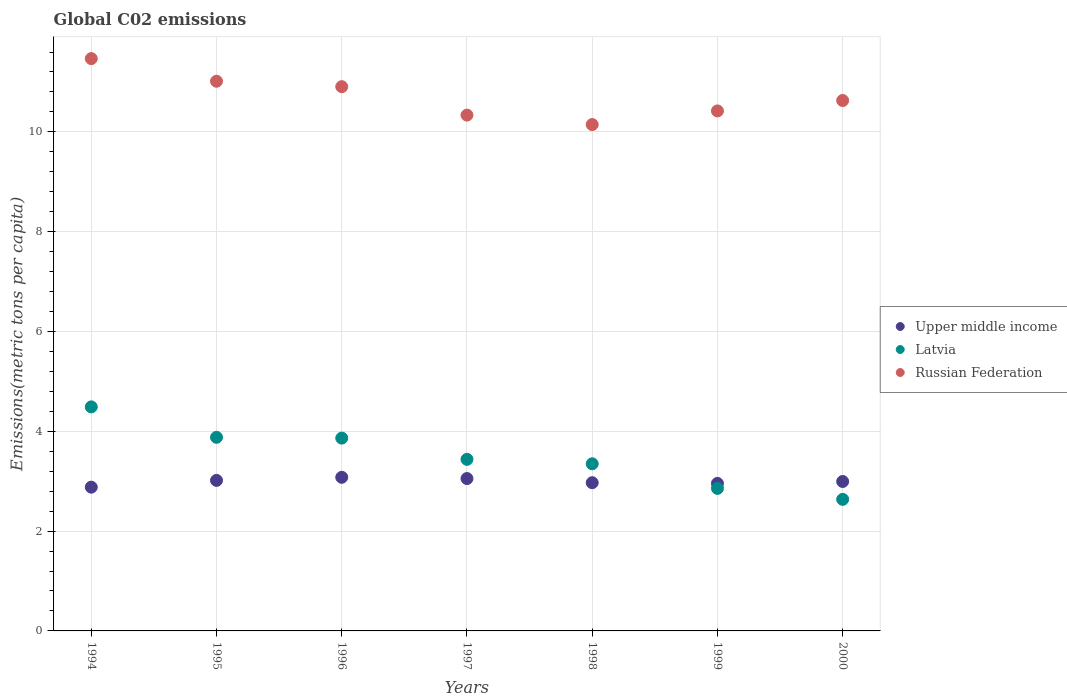How many different coloured dotlines are there?
Give a very brief answer. 3. Is the number of dotlines equal to the number of legend labels?
Your answer should be very brief. Yes. What is the amount of CO2 emitted in in Upper middle income in 2000?
Give a very brief answer. 2.99. Across all years, what is the maximum amount of CO2 emitted in in Upper middle income?
Your answer should be very brief. 3.08. Across all years, what is the minimum amount of CO2 emitted in in Upper middle income?
Give a very brief answer. 2.88. What is the total amount of CO2 emitted in in Latvia in the graph?
Ensure brevity in your answer.  24.51. What is the difference between the amount of CO2 emitted in in Latvia in 1997 and that in 1998?
Your response must be concise. 0.09. What is the difference between the amount of CO2 emitted in in Latvia in 1995 and the amount of CO2 emitted in in Upper middle income in 2000?
Offer a very short reply. 0.88. What is the average amount of CO2 emitted in in Upper middle income per year?
Provide a short and direct response. 2.99. In the year 1997, what is the difference between the amount of CO2 emitted in in Latvia and amount of CO2 emitted in in Upper middle income?
Provide a succinct answer. 0.39. What is the ratio of the amount of CO2 emitted in in Russian Federation in 1995 to that in 1998?
Provide a short and direct response. 1.09. Is the amount of CO2 emitted in in Russian Federation in 1994 less than that in 1995?
Keep it short and to the point. No. Is the difference between the amount of CO2 emitted in in Latvia in 1996 and 2000 greater than the difference between the amount of CO2 emitted in in Upper middle income in 1996 and 2000?
Your answer should be very brief. Yes. What is the difference between the highest and the second highest amount of CO2 emitted in in Russian Federation?
Offer a very short reply. 0.45. What is the difference between the highest and the lowest amount of CO2 emitted in in Latvia?
Provide a short and direct response. 1.85. Does the amount of CO2 emitted in in Latvia monotonically increase over the years?
Your answer should be compact. No. Is the amount of CO2 emitted in in Russian Federation strictly less than the amount of CO2 emitted in in Upper middle income over the years?
Offer a terse response. No. How many years are there in the graph?
Your answer should be compact. 7. What is the difference between two consecutive major ticks on the Y-axis?
Your answer should be compact. 2. Are the values on the major ticks of Y-axis written in scientific E-notation?
Provide a short and direct response. No. Where does the legend appear in the graph?
Give a very brief answer. Center right. How many legend labels are there?
Your answer should be compact. 3. What is the title of the graph?
Provide a short and direct response. Global C02 emissions. Does "Latin America(all income levels)" appear as one of the legend labels in the graph?
Keep it short and to the point. No. What is the label or title of the X-axis?
Provide a short and direct response. Years. What is the label or title of the Y-axis?
Your answer should be compact. Emissions(metric tons per capita). What is the Emissions(metric tons per capita) of Upper middle income in 1994?
Offer a terse response. 2.88. What is the Emissions(metric tons per capita) in Latvia in 1994?
Your response must be concise. 4.49. What is the Emissions(metric tons per capita) of Russian Federation in 1994?
Provide a short and direct response. 11.47. What is the Emissions(metric tons per capita) in Upper middle income in 1995?
Provide a short and direct response. 3.02. What is the Emissions(metric tons per capita) in Latvia in 1995?
Offer a terse response. 3.88. What is the Emissions(metric tons per capita) in Russian Federation in 1995?
Provide a succinct answer. 11.01. What is the Emissions(metric tons per capita) in Upper middle income in 1996?
Keep it short and to the point. 3.08. What is the Emissions(metric tons per capita) in Latvia in 1996?
Offer a very short reply. 3.86. What is the Emissions(metric tons per capita) in Russian Federation in 1996?
Your answer should be compact. 10.91. What is the Emissions(metric tons per capita) of Upper middle income in 1997?
Offer a terse response. 3.05. What is the Emissions(metric tons per capita) in Latvia in 1997?
Provide a short and direct response. 3.44. What is the Emissions(metric tons per capita) in Russian Federation in 1997?
Provide a short and direct response. 10.34. What is the Emissions(metric tons per capita) in Upper middle income in 1998?
Provide a short and direct response. 2.97. What is the Emissions(metric tons per capita) of Latvia in 1998?
Make the answer very short. 3.35. What is the Emissions(metric tons per capita) in Russian Federation in 1998?
Provide a succinct answer. 10.15. What is the Emissions(metric tons per capita) of Upper middle income in 1999?
Ensure brevity in your answer.  2.96. What is the Emissions(metric tons per capita) of Latvia in 1999?
Your answer should be very brief. 2.86. What is the Emissions(metric tons per capita) of Russian Federation in 1999?
Keep it short and to the point. 10.42. What is the Emissions(metric tons per capita) in Upper middle income in 2000?
Your answer should be compact. 2.99. What is the Emissions(metric tons per capita) in Latvia in 2000?
Provide a short and direct response. 2.64. What is the Emissions(metric tons per capita) of Russian Federation in 2000?
Offer a terse response. 10.63. Across all years, what is the maximum Emissions(metric tons per capita) of Upper middle income?
Offer a very short reply. 3.08. Across all years, what is the maximum Emissions(metric tons per capita) of Latvia?
Offer a very short reply. 4.49. Across all years, what is the maximum Emissions(metric tons per capita) of Russian Federation?
Give a very brief answer. 11.47. Across all years, what is the minimum Emissions(metric tons per capita) in Upper middle income?
Make the answer very short. 2.88. Across all years, what is the minimum Emissions(metric tons per capita) in Latvia?
Offer a terse response. 2.64. Across all years, what is the minimum Emissions(metric tons per capita) of Russian Federation?
Provide a short and direct response. 10.15. What is the total Emissions(metric tons per capita) of Upper middle income in the graph?
Offer a terse response. 20.95. What is the total Emissions(metric tons per capita) of Latvia in the graph?
Keep it short and to the point. 24.51. What is the total Emissions(metric tons per capita) in Russian Federation in the graph?
Your answer should be compact. 74.92. What is the difference between the Emissions(metric tons per capita) in Upper middle income in 1994 and that in 1995?
Offer a terse response. -0.14. What is the difference between the Emissions(metric tons per capita) in Latvia in 1994 and that in 1995?
Offer a very short reply. 0.61. What is the difference between the Emissions(metric tons per capita) in Russian Federation in 1994 and that in 1995?
Provide a short and direct response. 0.45. What is the difference between the Emissions(metric tons per capita) in Upper middle income in 1994 and that in 1996?
Offer a terse response. -0.2. What is the difference between the Emissions(metric tons per capita) in Latvia in 1994 and that in 1996?
Provide a short and direct response. 0.63. What is the difference between the Emissions(metric tons per capita) in Russian Federation in 1994 and that in 1996?
Offer a terse response. 0.56. What is the difference between the Emissions(metric tons per capita) of Upper middle income in 1994 and that in 1997?
Provide a succinct answer. -0.17. What is the difference between the Emissions(metric tons per capita) in Latvia in 1994 and that in 1997?
Make the answer very short. 1.05. What is the difference between the Emissions(metric tons per capita) of Russian Federation in 1994 and that in 1997?
Offer a very short reply. 1.13. What is the difference between the Emissions(metric tons per capita) in Upper middle income in 1994 and that in 1998?
Offer a very short reply. -0.09. What is the difference between the Emissions(metric tons per capita) of Latvia in 1994 and that in 1998?
Give a very brief answer. 1.14. What is the difference between the Emissions(metric tons per capita) in Russian Federation in 1994 and that in 1998?
Your response must be concise. 1.32. What is the difference between the Emissions(metric tons per capita) of Upper middle income in 1994 and that in 1999?
Keep it short and to the point. -0.08. What is the difference between the Emissions(metric tons per capita) of Latvia in 1994 and that in 1999?
Your answer should be very brief. 1.63. What is the difference between the Emissions(metric tons per capita) of Russian Federation in 1994 and that in 1999?
Give a very brief answer. 1.05. What is the difference between the Emissions(metric tons per capita) of Upper middle income in 1994 and that in 2000?
Ensure brevity in your answer.  -0.11. What is the difference between the Emissions(metric tons per capita) of Latvia in 1994 and that in 2000?
Provide a succinct answer. 1.85. What is the difference between the Emissions(metric tons per capita) in Russian Federation in 1994 and that in 2000?
Give a very brief answer. 0.84. What is the difference between the Emissions(metric tons per capita) in Upper middle income in 1995 and that in 1996?
Your answer should be very brief. -0.06. What is the difference between the Emissions(metric tons per capita) of Latvia in 1995 and that in 1996?
Offer a terse response. 0.02. What is the difference between the Emissions(metric tons per capita) in Russian Federation in 1995 and that in 1996?
Provide a succinct answer. 0.11. What is the difference between the Emissions(metric tons per capita) of Upper middle income in 1995 and that in 1997?
Offer a very short reply. -0.04. What is the difference between the Emissions(metric tons per capita) in Latvia in 1995 and that in 1997?
Ensure brevity in your answer.  0.44. What is the difference between the Emissions(metric tons per capita) in Russian Federation in 1995 and that in 1997?
Provide a succinct answer. 0.68. What is the difference between the Emissions(metric tons per capita) in Upper middle income in 1995 and that in 1998?
Offer a very short reply. 0.05. What is the difference between the Emissions(metric tons per capita) of Latvia in 1995 and that in 1998?
Provide a succinct answer. 0.53. What is the difference between the Emissions(metric tons per capita) of Russian Federation in 1995 and that in 1998?
Give a very brief answer. 0.87. What is the difference between the Emissions(metric tons per capita) of Upper middle income in 1995 and that in 1999?
Keep it short and to the point. 0.06. What is the difference between the Emissions(metric tons per capita) in Latvia in 1995 and that in 1999?
Your answer should be very brief. 1.02. What is the difference between the Emissions(metric tons per capita) in Russian Federation in 1995 and that in 1999?
Your response must be concise. 0.59. What is the difference between the Emissions(metric tons per capita) in Upper middle income in 1995 and that in 2000?
Ensure brevity in your answer.  0.02. What is the difference between the Emissions(metric tons per capita) of Latvia in 1995 and that in 2000?
Give a very brief answer. 1.24. What is the difference between the Emissions(metric tons per capita) in Russian Federation in 1995 and that in 2000?
Offer a terse response. 0.39. What is the difference between the Emissions(metric tons per capita) in Upper middle income in 1996 and that in 1997?
Your response must be concise. 0.03. What is the difference between the Emissions(metric tons per capita) in Latvia in 1996 and that in 1997?
Ensure brevity in your answer.  0.43. What is the difference between the Emissions(metric tons per capita) of Russian Federation in 1996 and that in 1997?
Give a very brief answer. 0.57. What is the difference between the Emissions(metric tons per capita) in Upper middle income in 1996 and that in 1998?
Your answer should be very brief. 0.11. What is the difference between the Emissions(metric tons per capita) of Latvia in 1996 and that in 1998?
Offer a terse response. 0.51. What is the difference between the Emissions(metric tons per capita) of Russian Federation in 1996 and that in 1998?
Offer a terse response. 0.76. What is the difference between the Emissions(metric tons per capita) of Upper middle income in 1996 and that in 1999?
Offer a terse response. 0.12. What is the difference between the Emissions(metric tons per capita) of Latvia in 1996 and that in 1999?
Offer a very short reply. 1.01. What is the difference between the Emissions(metric tons per capita) of Russian Federation in 1996 and that in 1999?
Offer a terse response. 0.49. What is the difference between the Emissions(metric tons per capita) of Upper middle income in 1996 and that in 2000?
Provide a short and direct response. 0.08. What is the difference between the Emissions(metric tons per capita) of Latvia in 1996 and that in 2000?
Provide a succinct answer. 1.23. What is the difference between the Emissions(metric tons per capita) of Russian Federation in 1996 and that in 2000?
Make the answer very short. 0.28. What is the difference between the Emissions(metric tons per capita) in Upper middle income in 1997 and that in 1998?
Ensure brevity in your answer.  0.08. What is the difference between the Emissions(metric tons per capita) of Latvia in 1997 and that in 1998?
Give a very brief answer. 0.09. What is the difference between the Emissions(metric tons per capita) in Russian Federation in 1997 and that in 1998?
Offer a terse response. 0.19. What is the difference between the Emissions(metric tons per capita) in Upper middle income in 1997 and that in 1999?
Provide a short and direct response. 0.1. What is the difference between the Emissions(metric tons per capita) of Latvia in 1997 and that in 1999?
Your answer should be very brief. 0.58. What is the difference between the Emissions(metric tons per capita) of Russian Federation in 1997 and that in 1999?
Keep it short and to the point. -0.08. What is the difference between the Emissions(metric tons per capita) in Upper middle income in 1997 and that in 2000?
Your response must be concise. 0.06. What is the difference between the Emissions(metric tons per capita) in Latvia in 1997 and that in 2000?
Your answer should be very brief. 0.8. What is the difference between the Emissions(metric tons per capita) of Russian Federation in 1997 and that in 2000?
Provide a succinct answer. -0.29. What is the difference between the Emissions(metric tons per capita) in Upper middle income in 1998 and that in 1999?
Offer a very short reply. 0.01. What is the difference between the Emissions(metric tons per capita) of Latvia in 1998 and that in 1999?
Your answer should be compact. 0.49. What is the difference between the Emissions(metric tons per capita) of Russian Federation in 1998 and that in 1999?
Make the answer very short. -0.27. What is the difference between the Emissions(metric tons per capita) in Upper middle income in 1998 and that in 2000?
Your response must be concise. -0.02. What is the difference between the Emissions(metric tons per capita) in Latvia in 1998 and that in 2000?
Provide a short and direct response. 0.71. What is the difference between the Emissions(metric tons per capita) in Russian Federation in 1998 and that in 2000?
Keep it short and to the point. -0.48. What is the difference between the Emissions(metric tons per capita) of Upper middle income in 1999 and that in 2000?
Your answer should be very brief. -0.04. What is the difference between the Emissions(metric tons per capita) in Latvia in 1999 and that in 2000?
Give a very brief answer. 0.22. What is the difference between the Emissions(metric tons per capita) of Russian Federation in 1999 and that in 2000?
Ensure brevity in your answer.  -0.21. What is the difference between the Emissions(metric tons per capita) of Upper middle income in 1994 and the Emissions(metric tons per capita) of Latvia in 1995?
Offer a terse response. -1. What is the difference between the Emissions(metric tons per capita) in Upper middle income in 1994 and the Emissions(metric tons per capita) in Russian Federation in 1995?
Ensure brevity in your answer.  -8.13. What is the difference between the Emissions(metric tons per capita) of Latvia in 1994 and the Emissions(metric tons per capita) of Russian Federation in 1995?
Offer a terse response. -6.53. What is the difference between the Emissions(metric tons per capita) in Upper middle income in 1994 and the Emissions(metric tons per capita) in Latvia in 1996?
Provide a succinct answer. -0.98. What is the difference between the Emissions(metric tons per capita) in Upper middle income in 1994 and the Emissions(metric tons per capita) in Russian Federation in 1996?
Give a very brief answer. -8.03. What is the difference between the Emissions(metric tons per capita) of Latvia in 1994 and the Emissions(metric tons per capita) of Russian Federation in 1996?
Your answer should be compact. -6.42. What is the difference between the Emissions(metric tons per capita) in Upper middle income in 1994 and the Emissions(metric tons per capita) in Latvia in 1997?
Your answer should be compact. -0.56. What is the difference between the Emissions(metric tons per capita) of Upper middle income in 1994 and the Emissions(metric tons per capita) of Russian Federation in 1997?
Make the answer very short. -7.46. What is the difference between the Emissions(metric tons per capita) in Latvia in 1994 and the Emissions(metric tons per capita) in Russian Federation in 1997?
Give a very brief answer. -5.85. What is the difference between the Emissions(metric tons per capita) in Upper middle income in 1994 and the Emissions(metric tons per capita) in Latvia in 1998?
Offer a very short reply. -0.47. What is the difference between the Emissions(metric tons per capita) in Upper middle income in 1994 and the Emissions(metric tons per capita) in Russian Federation in 1998?
Provide a short and direct response. -7.27. What is the difference between the Emissions(metric tons per capita) of Latvia in 1994 and the Emissions(metric tons per capita) of Russian Federation in 1998?
Ensure brevity in your answer.  -5.66. What is the difference between the Emissions(metric tons per capita) in Upper middle income in 1994 and the Emissions(metric tons per capita) in Latvia in 1999?
Provide a short and direct response. 0.02. What is the difference between the Emissions(metric tons per capita) of Upper middle income in 1994 and the Emissions(metric tons per capita) of Russian Federation in 1999?
Your answer should be very brief. -7.54. What is the difference between the Emissions(metric tons per capita) of Latvia in 1994 and the Emissions(metric tons per capita) of Russian Federation in 1999?
Make the answer very short. -5.93. What is the difference between the Emissions(metric tons per capita) in Upper middle income in 1994 and the Emissions(metric tons per capita) in Latvia in 2000?
Make the answer very short. 0.24. What is the difference between the Emissions(metric tons per capita) of Upper middle income in 1994 and the Emissions(metric tons per capita) of Russian Federation in 2000?
Your answer should be compact. -7.75. What is the difference between the Emissions(metric tons per capita) in Latvia in 1994 and the Emissions(metric tons per capita) in Russian Federation in 2000?
Your answer should be compact. -6.14. What is the difference between the Emissions(metric tons per capita) in Upper middle income in 1995 and the Emissions(metric tons per capita) in Latvia in 1996?
Provide a short and direct response. -0.85. What is the difference between the Emissions(metric tons per capita) in Upper middle income in 1995 and the Emissions(metric tons per capita) in Russian Federation in 1996?
Make the answer very short. -7.89. What is the difference between the Emissions(metric tons per capita) in Latvia in 1995 and the Emissions(metric tons per capita) in Russian Federation in 1996?
Give a very brief answer. -7.03. What is the difference between the Emissions(metric tons per capita) of Upper middle income in 1995 and the Emissions(metric tons per capita) of Latvia in 1997?
Provide a succinct answer. -0.42. What is the difference between the Emissions(metric tons per capita) in Upper middle income in 1995 and the Emissions(metric tons per capita) in Russian Federation in 1997?
Provide a succinct answer. -7.32. What is the difference between the Emissions(metric tons per capita) of Latvia in 1995 and the Emissions(metric tons per capita) of Russian Federation in 1997?
Offer a terse response. -6.46. What is the difference between the Emissions(metric tons per capita) in Upper middle income in 1995 and the Emissions(metric tons per capita) in Latvia in 1998?
Your answer should be compact. -0.33. What is the difference between the Emissions(metric tons per capita) in Upper middle income in 1995 and the Emissions(metric tons per capita) in Russian Federation in 1998?
Your answer should be compact. -7.13. What is the difference between the Emissions(metric tons per capita) in Latvia in 1995 and the Emissions(metric tons per capita) in Russian Federation in 1998?
Keep it short and to the point. -6.27. What is the difference between the Emissions(metric tons per capita) of Upper middle income in 1995 and the Emissions(metric tons per capita) of Latvia in 1999?
Offer a terse response. 0.16. What is the difference between the Emissions(metric tons per capita) in Upper middle income in 1995 and the Emissions(metric tons per capita) in Russian Federation in 1999?
Provide a succinct answer. -7.4. What is the difference between the Emissions(metric tons per capita) in Latvia in 1995 and the Emissions(metric tons per capita) in Russian Federation in 1999?
Provide a short and direct response. -6.54. What is the difference between the Emissions(metric tons per capita) in Upper middle income in 1995 and the Emissions(metric tons per capita) in Latvia in 2000?
Offer a terse response. 0.38. What is the difference between the Emissions(metric tons per capita) in Upper middle income in 1995 and the Emissions(metric tons per capita) in Russian Federation in 2000?
Offer a terse response. -7.61. What is the difference between the Emissions(metric tons per capita) in Latvia in 1995 and the Emissions(metric tons per capita) in Russian Federation in 2000?
Your answer should be very brief. -6.75. What is the difference between the Emissions(metric tons per capita) of Upper middle income in 1996 and the Emissions(metric tons per capita) of Latvia in 1997?
Keep it short and to the point. -0.36. What is the difference between the Emissions(metric tons per capita) of Upper middle income in 1996 and the Emissions(metric tons per capita) of Russian Federation in 1997?
Your answer should be compact. -7.26. What is the difference between the Emissions(metric tons per capita) of Latvia in 1996 and the Emissions(metric tons per capita) of Russian Federation in 1997?
Provide a short and direct response. -6.47. What is the difference between the Emissions(metric tons per capita) in Upper middle income in 1996 and the Emissions(metric tons per capita) in Latvia in 1998?
Provide a short and direct response. -0.27. What is the difference between the Emissions(metric tons per capita) of Upper middle income in 1996 and the Emissions(metric tons per capita) of Russian Federation in 1998?
Your answer should be very brief. -7.07. What is the difference between the Emissions(metric tons per capita) in Latvia in 1996 and the Emissions(metric tons per capita) in Russian Federation in 1998?
Your response must be concise. -6.28. What is the difference between the Emissions(metric tons per capita) of Upper middle income in 1996 and the Emissions(metric tons per capita) of Latvia in 1999?
Offer a very short reply. 0.22. What is the difference between the Emissions(metric tons per capita) of Upper middle income in 1996 and the Emissions(metric tons per capita) of Russian Federation in 1999?
Make the answer very short. -7.34. What is the difference between the Emissions(metric tons per capita) of Latvia in 1996 and the Emissions(metric tons per capita) of Russian Federation in 1999?
Keep it short and to the point. -6.56. What is the difference between the Emissions(metric tons per capita) of Upper middle income in 1996 and the Emissions(metric tons per capita) of Latvia in 2000?
Your response must be concise. 0.44. What is the difference between the Emissions(metric tons per capita) in Upper middle income in 1996 and the Emissions(metric tons per capita) in Russian Federation in 2000?
Your response must be concise. -7.55. What is the difference between the Emissions(metric tons per capita) of Latvia in 1996 and the Emissions(metric tons per capita) of Russian Federation in 2000?
Your answer should be very brief. -6.76. What is the difference between the Emissions(metric tons per capita) in Upper middle income in 1997 and the Emissions(metric tons per capita) in Latvia in 1998?
Offer a very short reply. -0.3. What is the difference between the Emissions(metric tons per capita) in Upper middle income in 1997 and the Emissions(metric tons per capita) in Russian Federation in 1998?
Offer a very short reply. -7.09. What is the difference between the Emissions(metric tons per capita) in Latvia in 1997 and the Emissions(metric tons per capita) in Russian Federation in 1998?
Keep it short and to the point. -6.71. What is the difference between the Emissions(metric tons per capita) in Upper middle income in 1997 and the Emissions(metric tons per capita) in Latvia in 1999?
Your answer should be very brief. 0.2. What is the difference between the Emissions(metric tons per capita) in Upper middle income in 1997 and the Emissions(metric tons per capita) in Russian Federation in 1999?
Provide a succinct answer. -7.37. What is the difference between the Emissions(metric tons per capita) in Latvia in 1997 and the Emissions(metric tons per capita) in Russian Federation in 1999?
Your answer should be compact. -6.98. What is the difference between the Emissions(metric tons per capita) of Upper middle income in 1997 and the Emissions(metric tons per capita) of Latvia in 2000?
Offer a terse response. 0.42. What is the difference between the Emissions(metric tons per capita) of Upper middle income in 1997 and the Emissions(metric tons per capita) of Russian Federation in 2000?
Your answer should be compact. -7.58. What is the difference between the Emissions(metric tons per capita) of Latvia in 1997 and the Emissions(metric tons per capita) of Russian Federation in 2000?
Keep it short and to the point. -7.19. What is the difference between the Emissions(metric tons per capita) of Upper middle income in 1998 and the Emissions(metric tons per capita) of Latvia in 1999?
Provide a succinct answer. 0.11. What is the difference between the Emissions(metric tons per capita) of Upper middle income in 1998 and the Emissions(metric tons per capita) of Russian Federation in 1999?
Your answer should be very brief. -7.45. What is the difference between the Emissions(metric tons per capita) of Latvia in 1998 and the Emissions(metric tons per capita) of Russian Federation in 1999?
Provide a short and direct response. -7.07. What is the difference between the Emissions(metric tons per capita) of Upper middle income in 1998 and the Emissions(metric tons per capita) of Latvia in 2000?
Provide a succinct answer. 0.33. What is the difference between the Emissions(metric tons per capita) in Upper middle income in 1998 and the Emissions(metric tons per capita) in Russian Federation in 2000?
Keep it short and to the point. -7.66. What is the difference between the Emissions(metric tons per capita) of Latvia in 1998 and the Emissions(metric tons per capita) of Russian Federation in 2000?
Offer a very short reply. -7.28. What is the difference between the Emissions(metric tons per capita) of Upper middle income in 1999 and the Emissions(metric tons per capita) of Latvia in 2000?
Make the answer very short. 0.32. What is the difference between the Emissions(metric tons per capita) of Upper middle income in 1999 and the Emissions(metric tons per capita) of Russian Federation in 2000?
Offer a terse response. -7.67. What is the difference between the Emissions(metric tons per capita) of Latvia in 1999 and the Emissions(metric tons per capita) of Russian Federation in 2000?
Provide a short and direct response. -7.77. What is the average Emissions(metric tons per capita) in Upper middle income per year?
Offer a very short reply. 2.99. What is the average Emissions(metric tons per capita) of Latvia per year?
Offer a very short reply. 3.5. What is the average Emissions(metric tons per capita) in Russian Federation per year?
Ensure brevity in your answer.  10.7. In the year 1994, what is the difference between the Emissions(metric tons per capita) of Upper middle income and Emissions(metric tons per capita) of Latvia?
Give a very brief answer. -1.61. In the year 1994, what is the difference between the Emissions(metric tons per capita) in Upper middle income and Emissions(metric tons per capita) in Russian Federation?
Make the answer very short. -8.59. In the year 1994, what is the difference between the Emissions(metric tons per capita) in Latvia and Emissions(metric tons per capita) in Russian Federation?
Your answer should be compact. -6.98. In the year 1995, what is the difference between the Emissions(metric tons per capita) of Upper middle income and Emissions(metric tons per capita) of Latvia?
Make the answer very short. -0.86. In the year 1995, what is the difference between the Emissions(metric tons per capita) in Upper middle income and Emissions(metric tons per capita) in Russian Federation?
Give a very brief answer. -8. In the year 1995, what is the difference between the Emissions(metric tons per capita) in Latvia and Emissions(metric tons per capita) in Russian Federation?
Offer a very short reply. -7.14. In the year 1996, what is the difference between the Emissions(metric tons per capita) in Upper middle income and Emissions(metric tons per capita) in Latvia?
Your response must be concise. -0.79. In the year 1996, what is the difference between the Emissions(metric tons per capita) in Upper middle income and Emissions(metric tons per capita) in Russian Federation?
Provide a succinct answer. -7.83. In the year 1996, what is the difference between the Emissions(metric tons per capita) of Latvia and Emissions(metric tons per capita) of Russian Federation?
Keep it short and to the point. -7.04. In the year 1997, what is the difference between the Emissions(metric tons per capita) in Upper middle income and Emissions(metric tons per capita) in Latvia?
Offer a terse response. -0.39. In the year 1997, what is the difference between the Emissions(metric tons per capita) of Upper middle income and Emissions(metric tons per capita) of Russian Federation?
Keep it short and to the point. -7.28. In the year 1997, what is the difference between the Emissions(metric tons per capita) of Latvia and Emissions(metric tons per capita) of Russian Federation?
Make the answer very short. -6.9. In the year 1998, what is the difference between the Emissions(metric tons per capita) of Upper middle income and Emissions(metric tons per capita) of Latvia?
Offer a very short reply. -0.38. In the year 1998, what is the difference between the Emissions(metric tons per capita) of Upper middle income and Emissions(metric tons per capita) of Russian Federation?
Your answer should be compact. -7.18. In the year 1998, what is the difference between the Emissions(metric tons per capita) in Latvia and Emissions(metric tons per capita) in Russian Federation?
Offer a terse response. -6.8. In the year 1999, what is the difference between the Emissions(metric tons per capita) of Upper middle income and Emissions(metric tons per capita) of Russian Federation?
Your answer should be very brief. -7.46. In the year 1999, what is the difference between the Emissions(metric tons per capita) in Latvia and Emissions(metric tons per capita) in Russian Federation?
Make the answer very short. -7.56. In the year 2000, what is the difference between the Emissions(metric tons per capita) in Upper middle income and Emissions(metric tons per capita) in Latvia?
Your response must be concise. 0.36. In the year 2000, what is the difference between the Emissions(metric tons per capita) in Upper middle income and Emissions(metric tons per capita) in Russian Federation?
Keep it short and to the point. -7.63. In the year 2000, what is the difference between the Emissions(metric tons per capita) in Latvia and Emissions(metric tons per capita) in Russian Federation?
Provide a succinct answer. -7.99. What is the ratio of the Emissions(metric tons per capita) of Upper middle income in 1994 to that in 1995?
Make the answer very short. 0.95. What is the ratio of the Emissions(metric tons per capita) of Latvia in 1994 to that in 1995?
Offer a very short reply. 1.16. What is the ratio of the Emissions(metric tons per capita) of Russian Federation in 1994 to that in 1995?
Your answer should be compact. 1.04. What is the ratio of the Emissions(metric tons per capita) of Upper middle income in 1994 to that in 1996?
Make the answer very short. 0.94. What is the ratio of the Emissions(metric tons per capita) in Latvia in 1994 to that in 1996?
Offer a very short reply. 1.16. What is the ratio of the Emissions(metric tons per capita) in Russian Federation in 1994 to that in 1996?
Ensure brevity in your answer.  1.05. What is the ratio of the Emissions(metric tons per capita) of Upper middle income in 1994 to that in 1997?
Give a very brief answer. 0.94. What is the ratio of the Emissions(metric tons per capita) of Latvia in 1994 to that in 1997?
Your answer should be very brief. 1.31. What is the ratio of the Emissions(metric tons per capita) of Russian Federation in 1994 to that in 1997?
Your answer should be very brief. 1.11. What is the ratio of the Emissions(metric tons per capita) in Upper middle income in 1994 to that in 1998?
Your answer should be very brief. 0.97. What is the ratio of the Emissions(metric tons per capita) of Latvia in 1994 to that in 1998?
Provide a succinct answer. 1.34. What is the ratio of the Emissions(metric tons per capita) in Russian Federation in 1994 to that in 1998?
Offer a terse response. 1.13. What is the ratio of the Emissions(metric tons per capita) in Upper middle income in 1994 to that in 1999?
Your answer should be very brief. 0.97. What is the ratio of the Emissions(metric tons per capita) in Latvia in 1994 to that in 1999?
Make the answer very short. 1.57. What is the ratio of the Emissions(metric tons per capita) in Russian Federation in 1994 to that in 1999?
Your answer should be very brief. 1.1. What is the ratio of the Emissions(metric tons per capita) in Latvia in 1994 to that in 2000?
Keep it short and to the point. 1.7. What is the ratio of the Emissions(metric tons per capita) of Russian Federation in 1994 to that in 2000?
Ensure brevity in your answer.  1.08. What is the ratio of the Emissions(metric tons per capita) in Latvia in 1995 to that in 1996?
Provide a short and direct response. 1. What is the ratio of the Emissions(metric tons per capita) of Latvia in 1995 to that in 1997?
Provide a short and direct response. 1.13. What is the ratio of the Emissions(metric tons per capita) of Russian Federation in 1995 to that in 1997?
Provide a succinct answer. 1.07. What is the ratio of the Emissions(metric tons per capita) in Upper middle income in 1995 to that in 1998?
Your answer should be very brief. 1.02. What is the ratio of the Emissions(metric tons per capita) in Latvia in 1995 to that in 1998?
Give a very brief answer. 1.16. What is the ratio of the Emissions(metric tons per capita) in Russian Federation in 1995 to that in 1998?
Your answer should be very brief. 1.09. What is the ratio of the Emissions(metric tons per capita) in Upper middle income in 1995 to that in 1999?
Provide a short and direct response. 1.02. What is the ratio of the Emissions(metric tons per capita) of Latvia in 1995 to that in 1999?
Give a very brief answer. 1.36. What is the ratio of the Emissions(metric tons per capita) in Russian Federation in 1995 to that in 1999?
Your response must be concise. 1.06. What is the ratio of the Emissions(metric tons per capita) in Upper middle income in 1995 to that in 2000?
Make the answer very short. 1.01. What is the ratio of the Emissions(metric tons per capita) of Latvia in 1995 to that in 2000?
Offer a very short reply. 1.47. What is the ratio of the Emissions(metric tons per capita) of Russian Federation in 1995 to that in 2000?
Your response must be concise. 1.04. What is the ratio of the Emissions(metric tons per capita) of Upper middle income in 1996 to that in 1997?
Your answer should be compact. 1.01. What is the ratio of the Emissions(metric tons per capita) in Latvia in 1996 to that in 1997?
Keep it short and to the point. 1.12. What is the ratio of the Emissions(metric tons per capita) of Russian Federation in 1996 to that in 1997?
Give a very brief answer. 1.06. What is the ratio of the Emissions(metric tons per capita) in Upper middle income in 1996 to that in 1998?
Ensure brevity in your answer.  1.04. What is the ratio of the Emissions(metric tons per capita) of Latvia in 1996 to that in 1998?
Ensure brevity in your answer.  1.15. What is the ratio of the Emissions(metric tons per capita) in Russian Federation in 1996 to that in 1998?
Keep it short and to the point. 1.07. What is the ratio of the Emissions(metric tons per capita) of Upper middle income in 1996 to that in 1999?
Provide a short and direct response. 1.04. What is the ratio of the Emissions(metric tons per capita) in Latvia in 1996 to that in 1999?
Your answer should be compact. 1.35. What is the ratio of the Emissions(metric tons per capita) in Russian Federation in 1996 to that in 1999?
Provide a succinct answer. 1.05. What is the ratio of the Emissions(metric tons per capita) of Upper middle income in 1996 to that in 2000?
Your answer should be very brief. 1.03. What is the ratio of the Emissions(metric tons per capita) of Latvia in 1996 to that in 2000?
Keep it short and to the point. 1.47. What is the ratio of the Emissions(metric tons per capita) in Russian Federation in 1996 to that in 2000?
Your response must be concise. 1.03. What is the ratio of the Emissions(metric tons per capita) of Upper middle income in 1997 to that in 1998?
Make the answer very short. 1.03. What is the ratio of the Emissions(metric tons per capita) of Latvia in 1997 to that in 1998?
Offer a terse response. 1.03. What is the ratio of the Emissions(metric tons per capita) in Russian Federation in 1997 to that in 1998?
Ensure brevity in your answer.  1.02. What is the ratio of the Emissions(metric tons per capita) of Upper middle income in 1997 to that in 1999?
Your response must be concise. 1.03. What is the ratio of the Emissions(metric tons per capita) in Latvia in 1997 to that in 1999?
Offer a terse response. 1.2. What is the ratio of the Emissions(metric tons per capita) of Upper middle income in 1997 to that in 2000?
Give a very brief answer. 1.02. What is the ratio of the Emissions(metric tons per capita) in Latvia in 1997 to that in 2000?
Offer a very short reply. 1.3. What is the ratio of the Emissions(metric tons per capita) of Russian Federation in 1997 to that in 2000?
Your answer should be very brief. 0.97. What is the ratio of the Emissions(metric tons per capita) in Upper middle income in 1998 to that in 1999?
Keep it short and to the point. 1. What is the ratio of the Emissions(metric tons per capita) of Latvia in 1998 to that in 1999?
Offer a very short reply. 1.17. What is the ratio of the Emissions(metric tons per capita) in Russian Federation in 1998 to that in 1999?
Give a very brief answer. 0.97. What is the ratio of the Emissions(metric tons per capita) of Upper middle income in 1998 to that in 2000?
Your response must be concise. 0.99. What is the ratio of the Emissions(metric tons per capita) in Latvia in 1998 to that in 2000?
Provide a short and direct response. 1.27. What is the ratio of the Emissions(metric tons per capita) of Russian Federation in 1998 to that in 2000?
Provide a succinct answer. 0.95. What is the ratio of the Emissions(metric tons per capita) in Upper middle income in 1999 to that in 2000?
Provide a short and direct response. 0.99. What is the ratio of the Emissions(metric tons per capita) of Latvia in 1999 to that in 2000?
Offer a terse response. 1.08. What is the ratio of the Emissions(metric tons per capita) of Russian Federation in 1999 to that in 2000?
Give a very brief answer. 0.98. What is the difference between the highest and the second highest Emissions(metric tons per capita) in Upper middle income?
Provide a short and direct response. 0.03. What is the difference between the highest and the second highest Emissions(metric tons per capita) of Latvia?
Your answer should be compact. 0.61. What is the difference between the highest and the second highest Emissions(metric tons per capita) of Russian Federation?
Make the answer very short. 0.45. What is the difference between the highest and the lowest Emissions(metric tons per capita) of Upper middle income?
Provide a succinct answer. 0.2. What is the difference between the highest and the lowest Emissions(metric tons per capita) in Latvia?
Provide a short and direct response. 1.85. What is the difference between the highest and the lowest Emissions(metric tons per capita) in Russian Federation?
Make the answer very short. 1.32. 